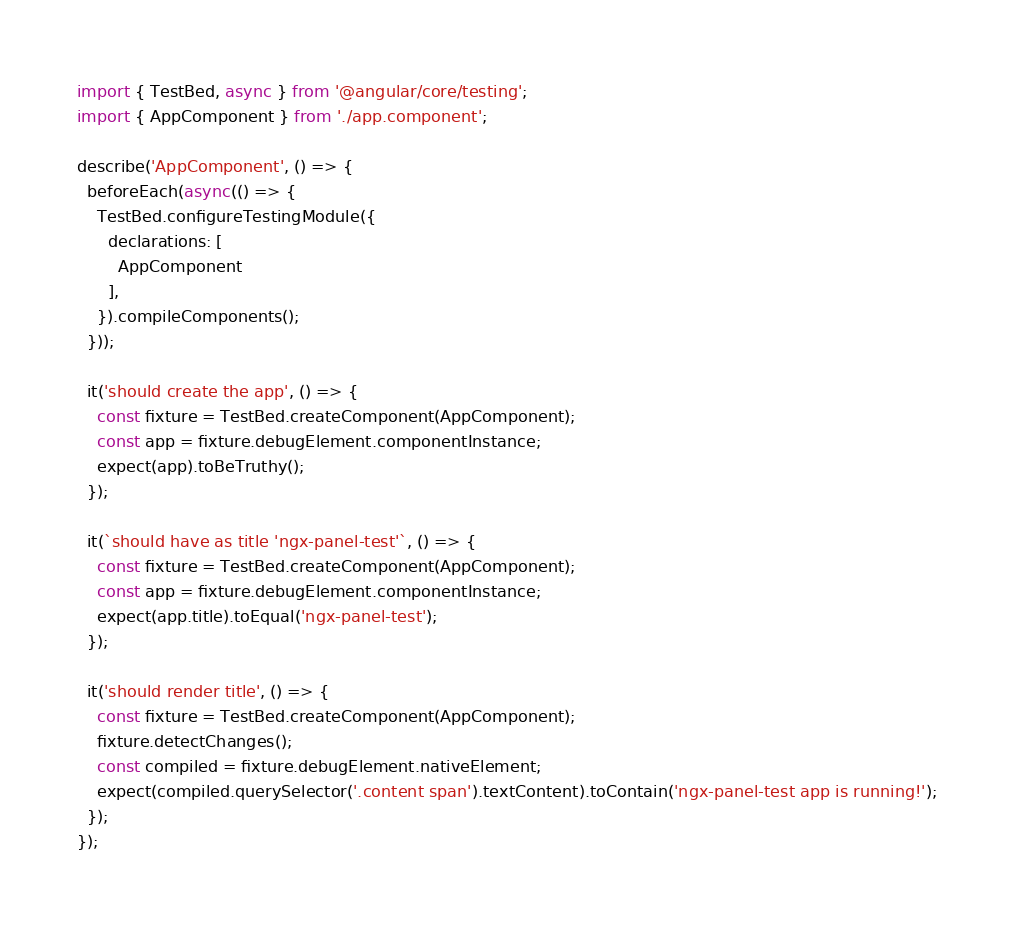<code> <loc_0><loc_0><loc_500><loc_500><_TypeScript_>import { TestBed, async } from '@angular/core/testing';
import { AppComponent } from './app.component';

describe('AppComponent', () => {
  beforeEach(async(() => {
    TestBed.configureTestingModule({
      declarations: [
        AppComponent
      ],
    }).compileComponents();
  }));

  it('should create the app', () => {
    const fixture = TestBed.createComponent(AppComponent);
    const app = fixture.debugElement.componentInstance;
    expect(app).toBeTruthy();
  });

  it(`should have as title 'ngx-panel-test'`, () => {
    const fixture = TestBed.createComponent(AppComponent);
    const app = fixture.debugElement.componentInstance;
    expect(app.title).toEqual('ngx-panel-test');
  });

  it('should render title', () => {
    const fixture = TestBed.createComponent(AppComponent);
    fixture.detectChanges();
    const compiled = fixture.debugElement.nativeElement;
    expect(compiled.querySelector('.content span').textContent).toContain('ngx-panel-test app is running!');
  });
});
</code> 